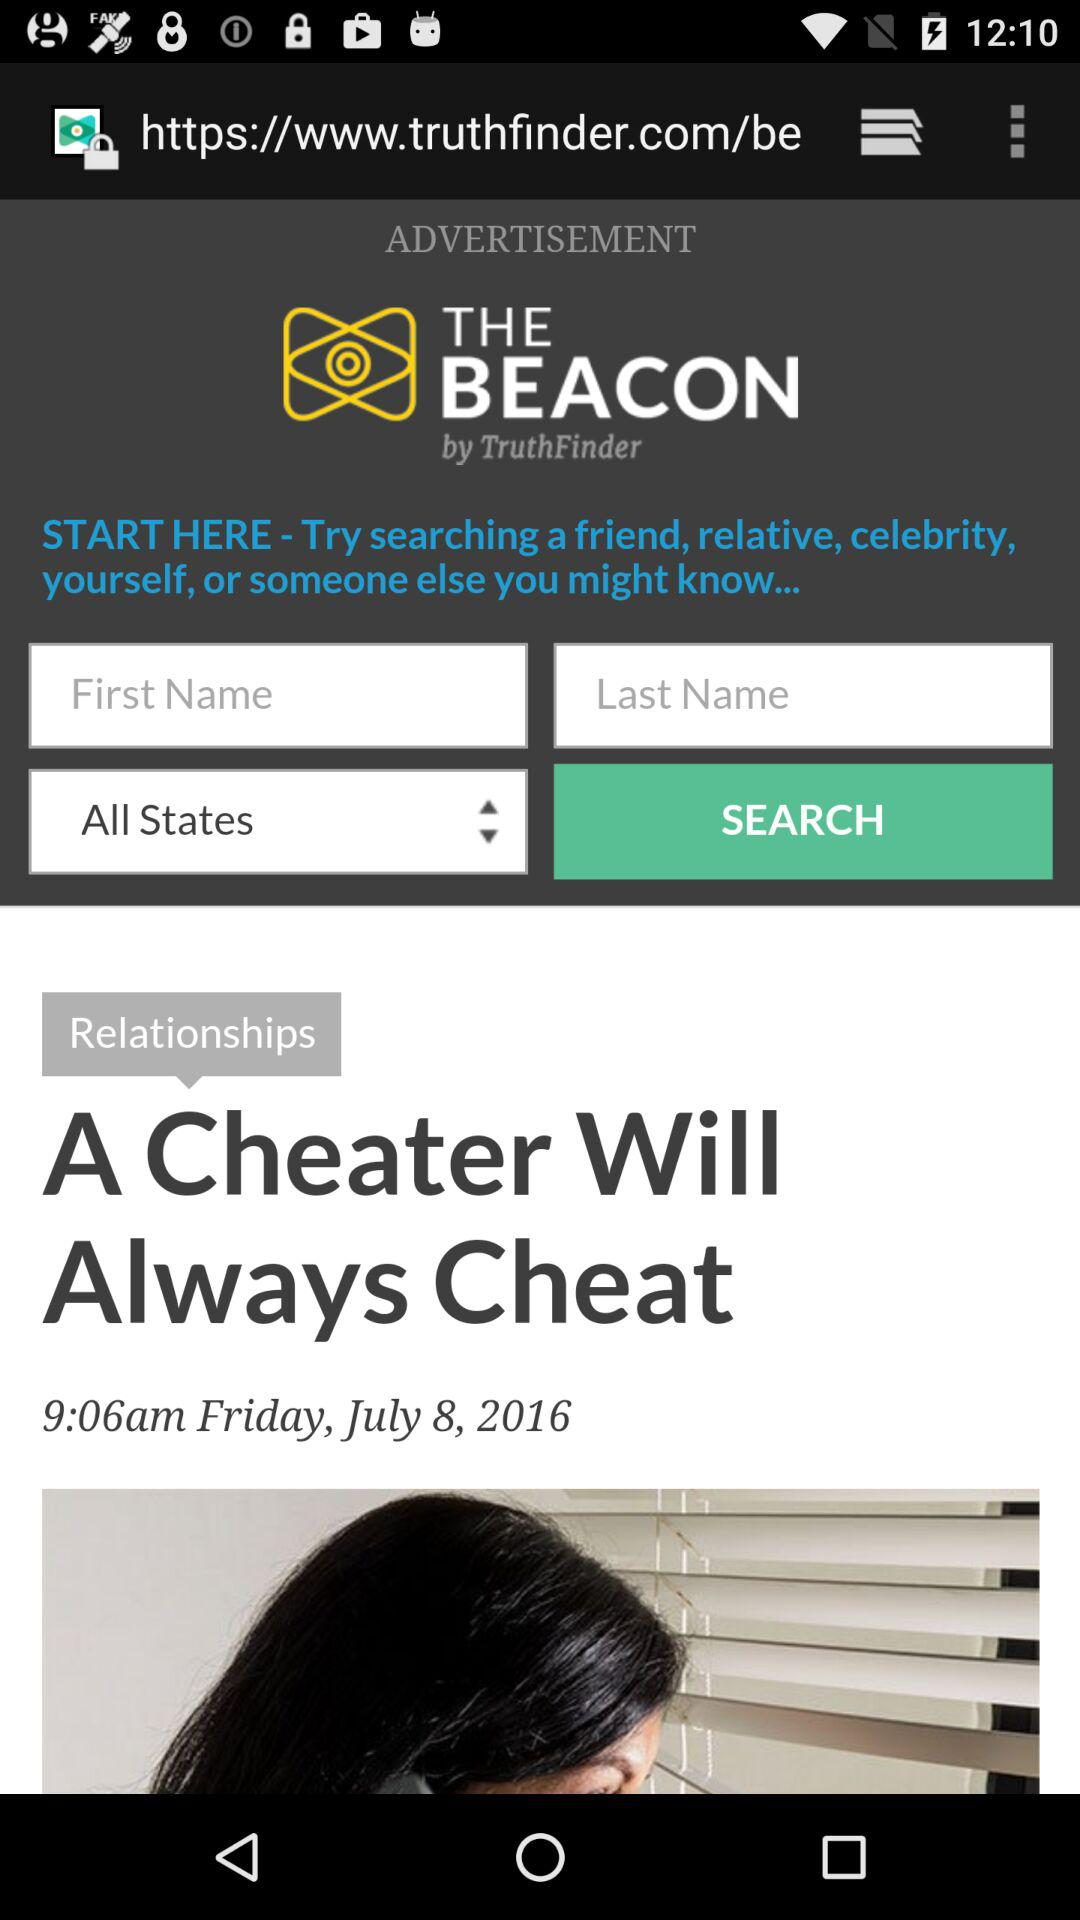What is the headline? The headline is "A Cheater Will Always Cheat". 